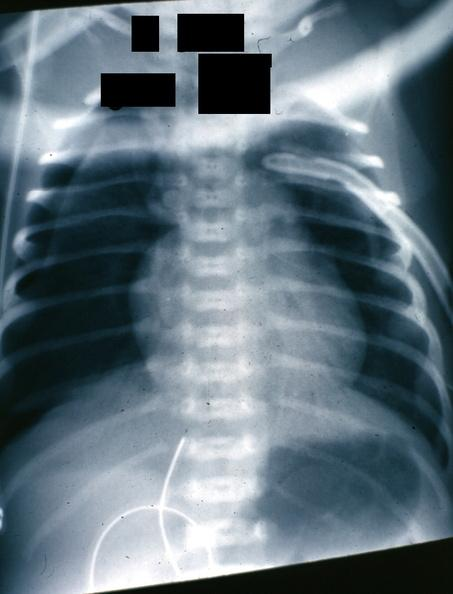what is present?
Answer the question using a single word or phrase. Pneumothorax x-ray infant 